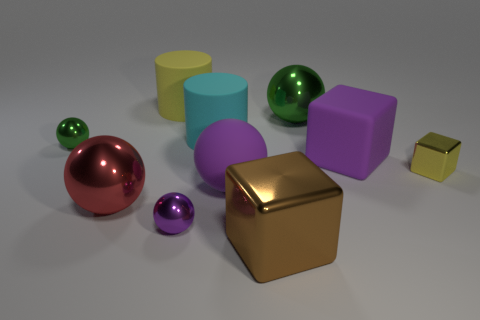The other ball that is the same color as the matte ball is what size?
Give a very brief answer. Small. How many other objects are there of the same size as the yellow cylinder?
Make the answer very short. 6. The rubber object right of the green ball that is to the right of the matte ball that is right of the large yellow thing is what color?
Keep it short and to the point. Purple. What number of other things are there of the same shape as the small purple shiny object?
Give a very brief answer. 4. What shape is the small shiny thing behind the tiny yellow metal thing?
Your answer should be compact. Sphere. There is a green object to the right of the large cyan matte thing; are there any large purple rubber objects that are to the right of it?
Make the answer very short. Yes. What is the color of the tiny metal object that is both on the left side of the large brown object and on the right side of the small green sphere?
Offer a terse response. Purple. There is a green shiny thing that is behind the rubber cylinder that is in front of the big yellow object; are there any rubber things in front of it?
Provide a succinct answer. Yes. There is another metallic object that is the same shape as the large brown thing; what size is it?
Your response must be concise. Small. Is there a gray metallic cylinder?
Keep it short and to the point. No. 